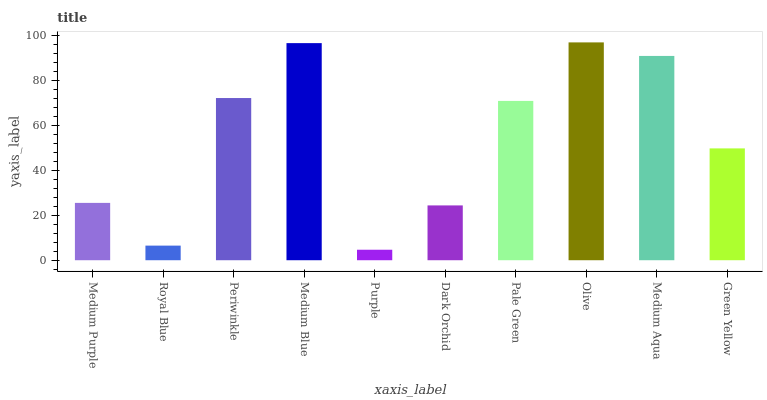Is Royal Blue the minimum?
Answer yes or no. No. Is Royal Blue the maximum?
Answer yes or no. No. Is Medium Purple greater than Royal Blue?
Answer yes or no. Yes. Is Royal Blue less than Medium Purple?
Answer yes or no. Yes. Is Royal Blue greater than Medium Purple?
Answer yes or no. No. Is Medium Purple less than Royal Blue?
Answer yes or no. No. Is Pale Green the high median?
Answer yes or no. Yes. Is Green Yellow the low median?
Answer yes or no. Yes. Is Medium Aqua the high median?
Answer yes or no. No. Is Pale Green the low median?
Answer yes or no. No. 